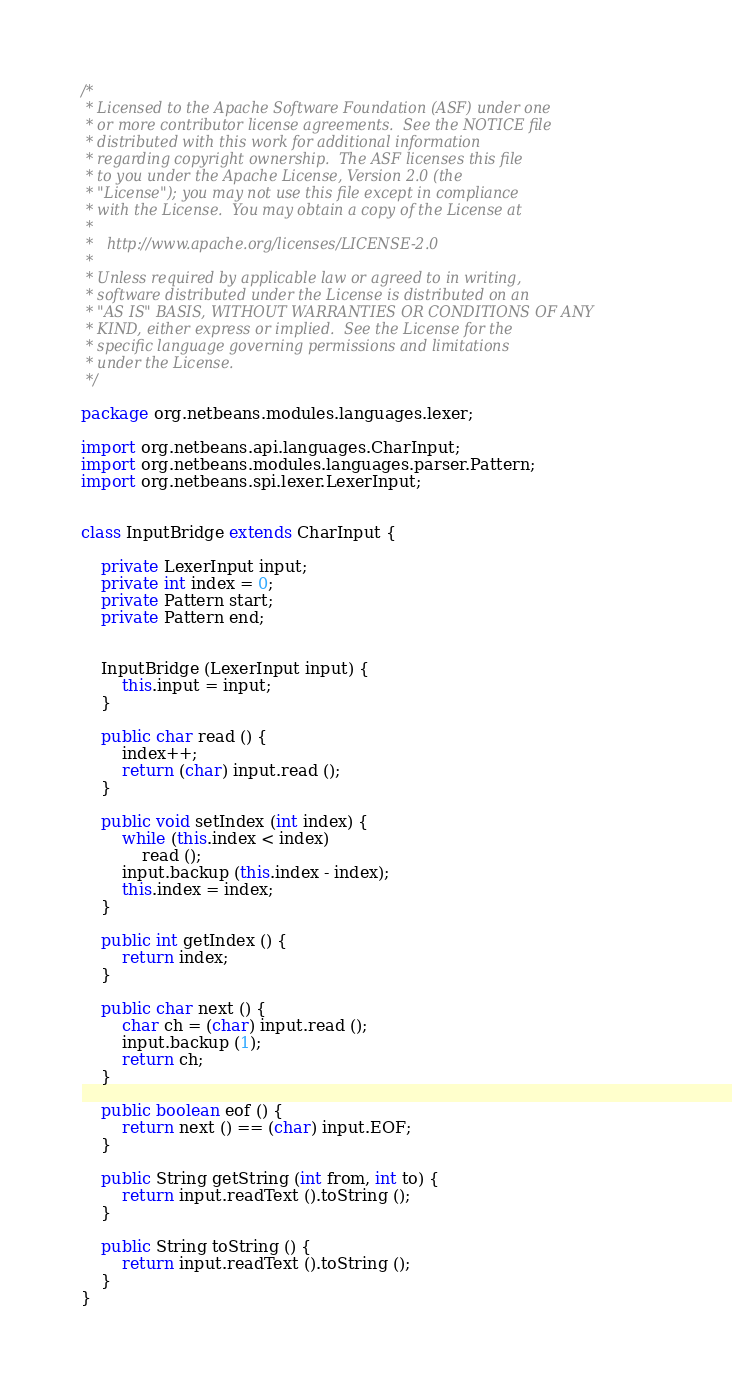<code> <loc_0><loc_0><loc_500><loc_500><_Java_>/*
 * Licensed to the Apache Software Foundation (ASF) under one
 * or more contributor license agreements.  See the NOTICE file
 * distributed with this work for additional information
 * regarding copyright ownership.  The ASF licenses this file
 * to you under the Apache License, Version 2.0 (the
 * "License"); you may not use this file except in compliance
 * with the License.  You may obtain a copy of the License at
 *
 *   http://www.apache.org/licenses/LICENSE-2.0
 *
 * Unless required by applicable law or agreed to in writing,
 * software distributed under the License is distributed on an
 * "AS IS" BASIS, WITHOUT WARRANTIES OR CONDITIONS OF ANY
 * KIND, either express or implied.  See the License for the
 * specific language governing permissions and limitations
 * under the License.
 */

package org.netbeans.modules.languages.lexer;

import org.netbeans.api.languages.CharInput;
import org.netbeans.modules.languages.parser.Pattern;
import org.netbeans.spi.lexer.LexerInput;


class InputBridge extends CharInput {

    private LexerInput input;
    private int index = 0;
    private Pattern start;
    private Pattern end;

    
    InputBridge (LexerInput input) {
        this.input = input;
    }

    public char read () {
        index++;
        return (char) input.read ();
    }

    public void setIndex (int index) {
        while (this.index < index)
            read ();
        input.backup (this.index - index);
        this.index = index;
    }

    public int getIndex () {
        return index;
    }

    public char next () {
        char ch = (char) input.read ();
        input.backup (1);
        return ch;
    }

    public boolean eof () {
        return next () == (char) input.EOF;
    }

    public String getString (int from, int to) {
        return input.readText ().toString ();
    }

    public String toString () {
        return input.readText ().toString ();
    }
}


</code> 